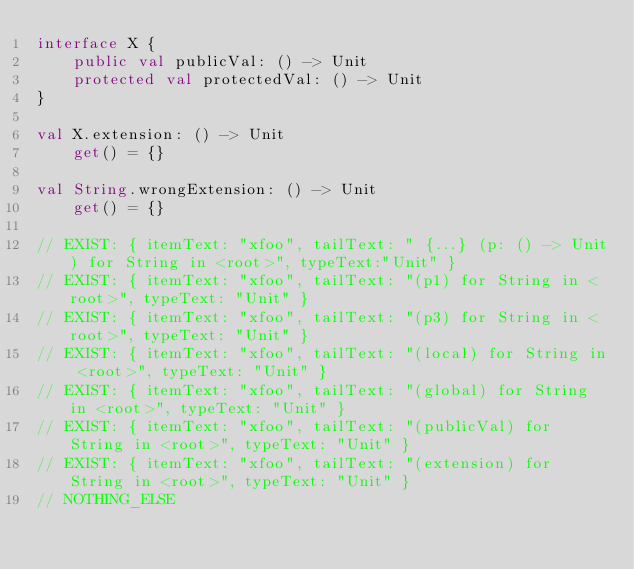Convert code to text. <code><loc_0><loc_0><loc_500><loc_500><_Kotlin_>interface X {
    public val publicVal: () -> Unit
    protected val protectedVal: () -> Unit
}

val X.extension: () -> Unit
    get() = {}

val String.wrongExtension: () -> Unit
    get() = {}

// EXIST: { itemText: "xfoo", tailText: " {...} (p: () -> Unit) for String in <root>", typeText:"Unit" }
// EXIST: { itemText: "xfoo", tailText: "(p1) for String in <root>", typeText: "Unit" }
// EXIST: { itemText: "xfoo", tailText: "(p3) for String in <root>", typeText: "Unit" }
// EXIST: { itemText: "xfoo", tailText: "(local) for String in <root>", typeText: "Unit" }
// EXIST: { itemText: "xfoo", tailText: "(global) for String in <root>", typeText: "Unit" }
// EXIST: { itemText: "xfoo", tailText: "(publicVal) for String in <root>", typeText: "Unit" }
// EXIST: { itemText: "xfoo", tailText: "(extension) for String in <root>", typeText: "Unit" }
// NOTHING_ELSE
</code> 